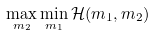<formula> <loc_0><loc_0><loc_500><loc_500>\max _ { m _ { 2 } } \min _ { m _ { 1 } } \mathcal { H } ( m _ { 1 } , m _ { 2 } )</formula> 